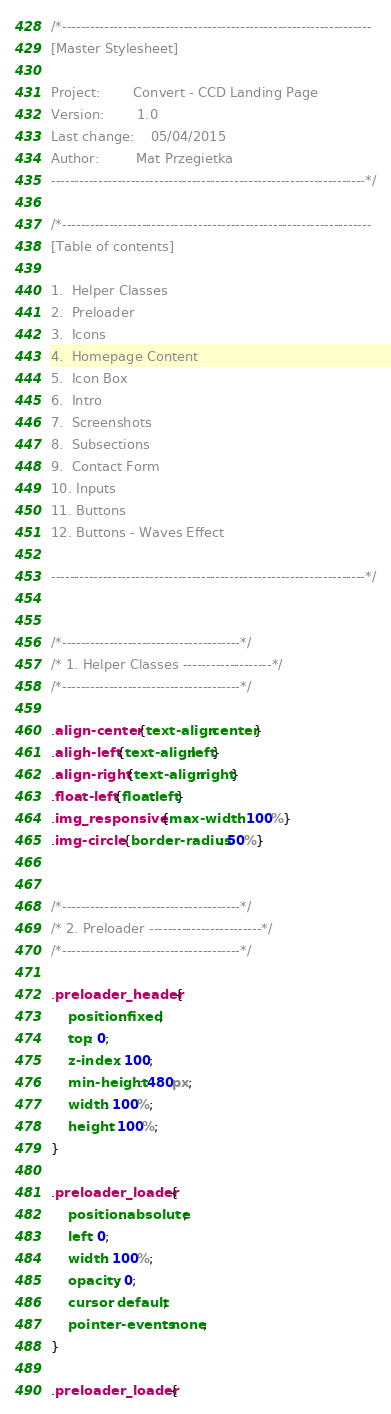Convert code to text. <code><loc_0><loc_0><loc_500><loc_500><_CSS_>/*------------------------------------------------------------------
[Master Stylesheet]

Project:	    Convert - CCD Landing Page
Version:	    1.0
Last change:	05/04/2015
Author:         Mat Przegietka
-------------------------------------------------------------------*/

/*------------------------------------------------------------------
[Table of contents]

1.  Helper Classes
2.  Preloader
3.  Icons
4.  Homepage Content
5.  Icon Box
6.  Intro
7.  Screenshots
8.  Subsections
9.  Contact Form
10. Inputs
11. Buttons
12. Buttons - Waves Effect

-------------------------------------------------------------------*/


/*--------------------------------------*/
/* 1. Helper Classes -------------------*/
/*--------------------------------------*/

.align-center {text-align:center}
.aligh-left {text-align:left}
.align-right {text-align:right}
.float-left {float:left}
.img_responsive {max-width: 100%}
.img-circle {border-radius: 50%}


/*--------------------------------------*/
/* 2. Preloader ------------------------*/
/*--------------------------------------*/

.preloader_header {
    position: fixed;
    top: 0;
    z-index: 100;
    min-height: 480px;
    width: 100%;
    height: 100%;
}

.preloader_loader {
    position: absolute;
    left: 0;
    width: 100%;
    opacity: 0;
    cursor: default;
    pointer-events: none;
}

.preloader_loader {</code> 